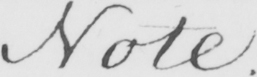What text is written in this handwritten line? Note . 